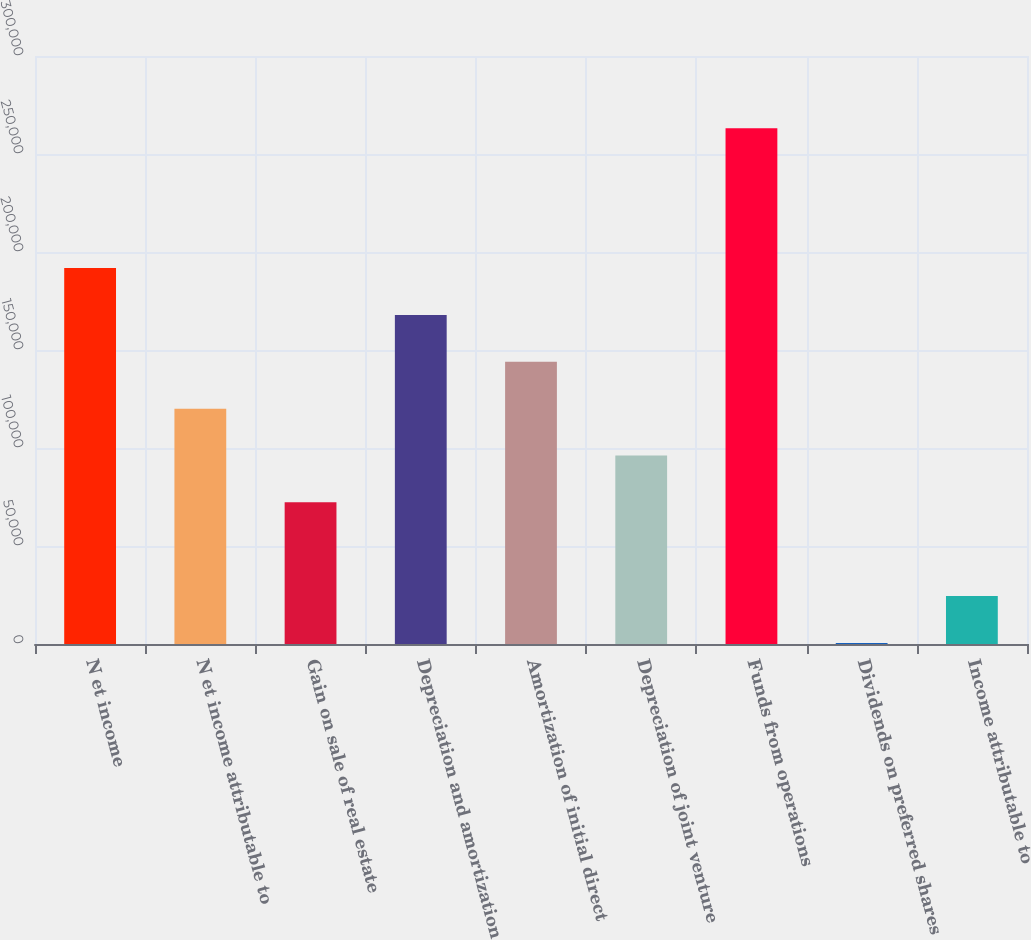Convert chart. <chart><loc_0><loc_0><loc_500><loc_500><bar_chart><fcel>N et income<fcel>N et income attributable to<fcel>Gain on sale of real estate<fcel>Depreciation and amortization<fcel>Amortization of initial direct<fcel>Depreciation of joint venture<fcel>Funds from operations<fcel>Dividends on preferred shares<fcel>Income attributable to<nl><fcel>191803<fcel>120080<fcel>72264.1<fcel>167895<fcel>143987<fcel>96171.8<fcel>263118<fcel>541<fcel>24448.7<nl></chart> 